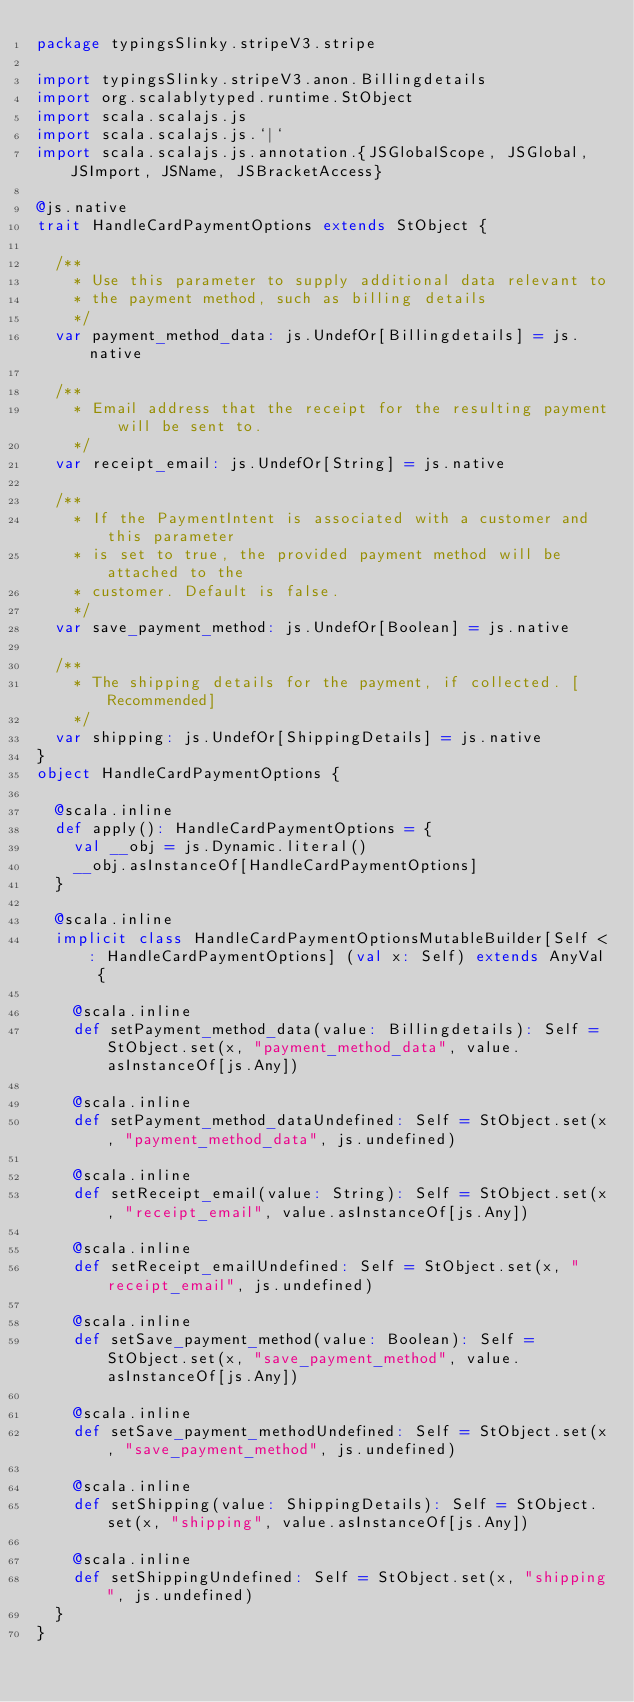<code> <loc_0><loc_0><loc_500><loc_500><_Scala_>package typingsSlinky.stripeV3.stripe

import typingsSlinky.stripeV3.anon.Billingdetails
import org.scalablytyped.runtime.StObject
import scala.scalajs.js
import scala.scalajs.js.`|`
import scala.scalajs.js.annotation.{JSGlobalScope, JSGlobal, JSImport, JSName, JSBracketAccess}

@js.native
trait HandleCardPaymentOptions extends StObject {
  
  /**
    * Use this parameter to supply additional data relevant to
    * the payment method, such as billing details
    */
  var payment_method_data: js.UndefOr[Billingdetails] = js.native
  
  /**
    * Email address that the receipt for the resulting payment will be sent to.
    */
  var receipt_email: js.UndefOr[String] = js.native
  
  /**
    * If the PaymentIntent is associated with a customer and this parameter
    * is set to true, the provided payment method will be attached to the
    * customer. Default is false.
    */
  var save_payment_method: js.UndefOr[Boolean] = js.native
  
  /**
    * The shipping details for the payment, if collected. [Recommended]
    */
  var shipping: js.UndefOr[ShippingDetails] = js.native
}
object HandleCardPaymentOptions {
  
  @scala.inline
  def apply(): HandleCardPaymentOptions = {
    val __obj = js.Dynamic.literal()
    __obj.asInstanceOf[HandleCardPaymentOptions]
  }
  
  @scala.inline
  implicit class HandleCardPaymentOptionsMutableBuilder[Self <: HandleCardPaymentOptions] (val x: Self) extends AnyVal {
    
    @scala.inline
    def setPayment_method_data(value: Billingdetails): Self = StObject.set(x, "payment_method_data", value.asInstanceOf[js.Any])
    
    @scala.inline
    def setPayment_method_dataUndefined: Self = StObject.set(x, "payment_method_data", js.undefined)
    
    @scala.inline
    def setReceipt_email(value: String): Self = StObject.set(x, "receipt_email", value.asInstanceOf[js.Any])
    
    @scala.inline
    def setReceipt_emailUndefined: Self = StObject.set(x, "receipt_email", js.undefined)
    
    @scala.inline
    def setSave_payment_method(value: Boolean): Self = StObject.set(x, "save_payment_method", value.asInstanceOf[js.Any])
    
    @scala.inline
    def setSave_payment_methodUndefined: Self = StObject.set(x, "save_payment_method", js.undefined)
    
    @scala.inline
    def setShipping(value: ShippingDetails): Self = StObject.set(x, "shipping", value.asInstanceOf[js.Any])
    
    @scala.inline
    def setShippingUndefined: Self = StObject.set(x, "shipping", js.undefined)
  }
}
</code> 